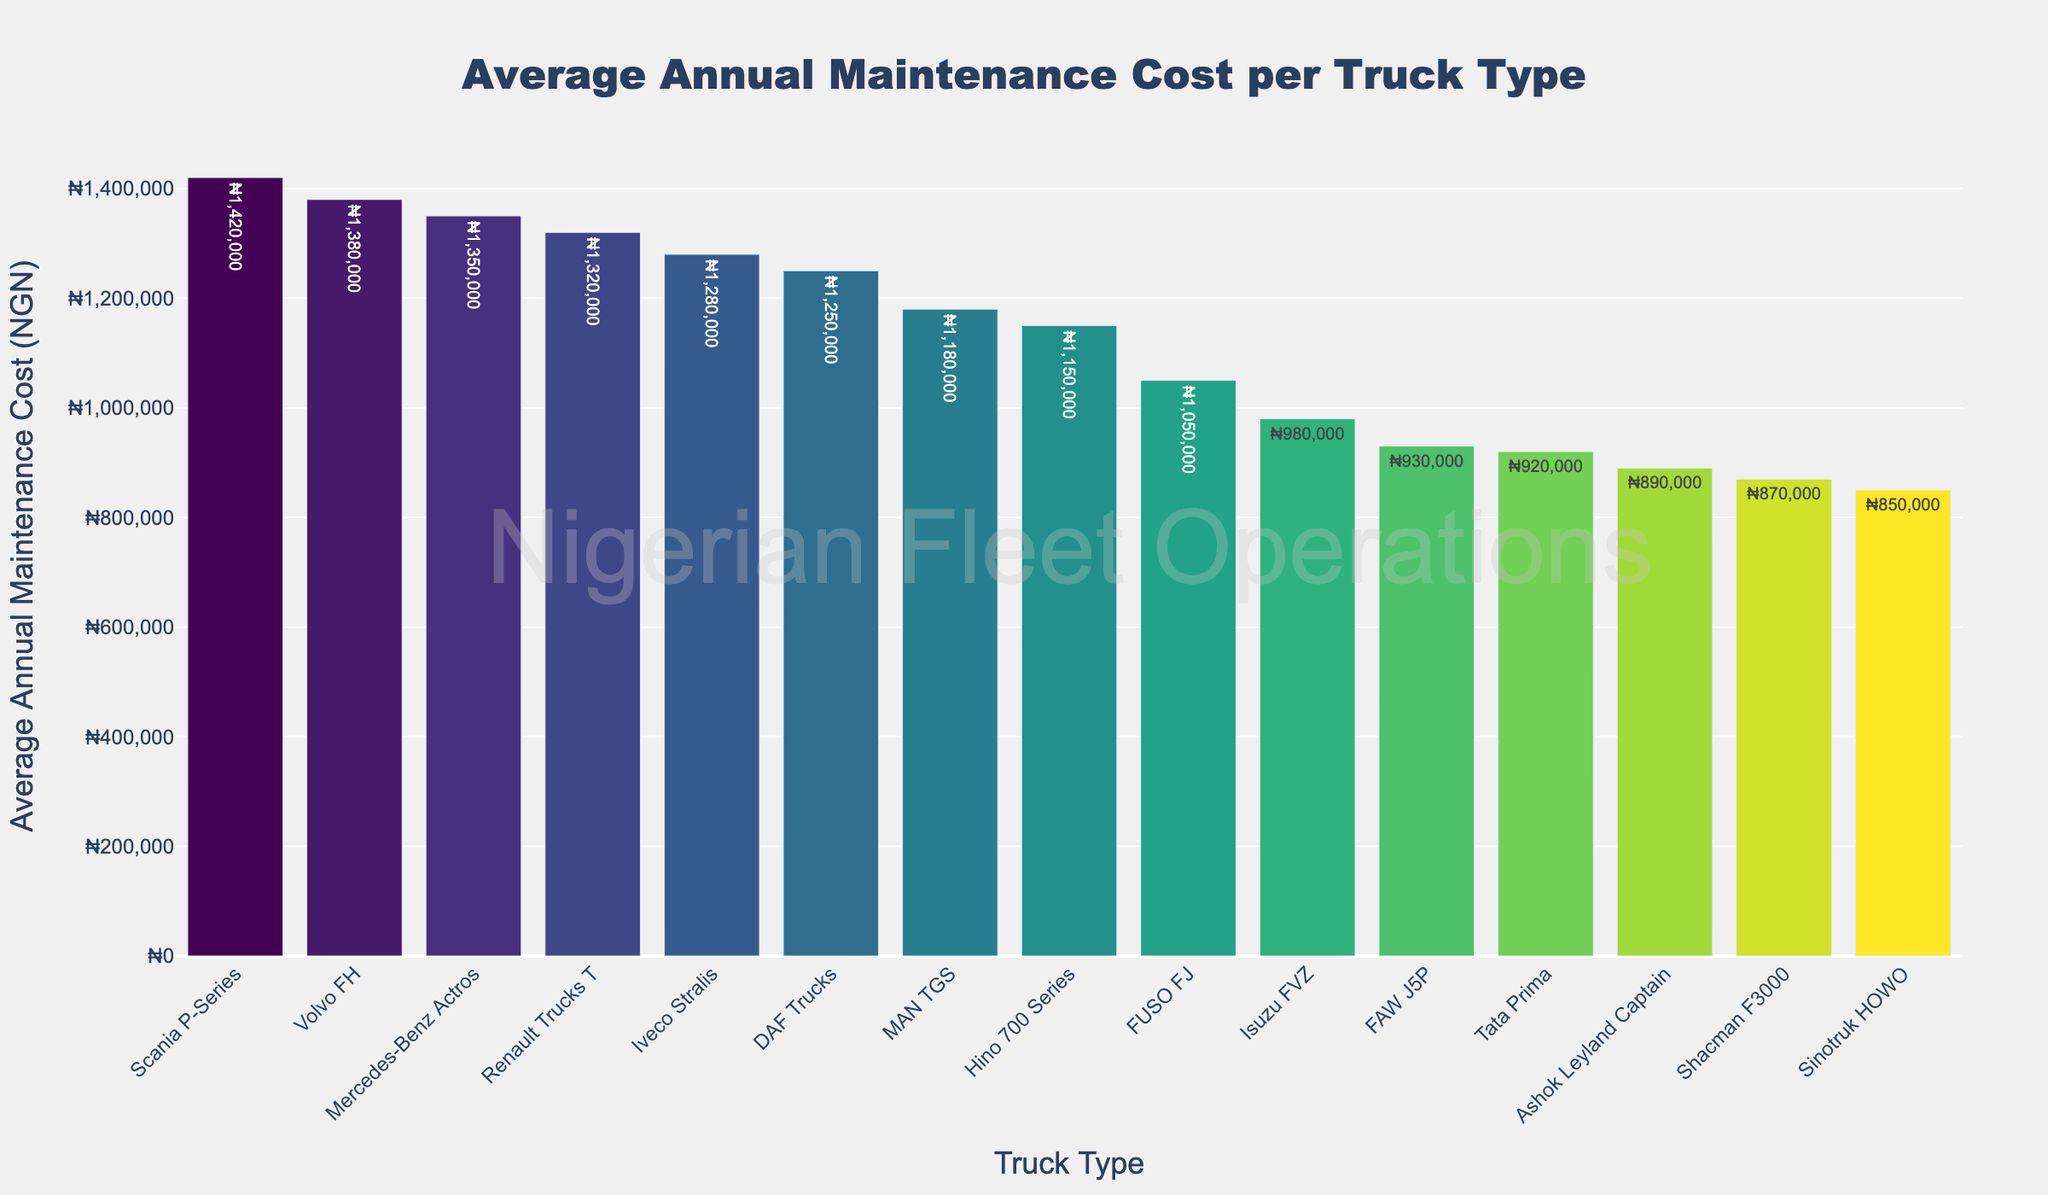Which truck type has the highest average annual maintenance cost? Look at the figure and identify the truck type with the tallest bar. The Scania P-Series has the tallest bar, indicating it has the highest average annual maintenance cost.
Answer: Scania P-Series Which truck type has the lowest average annual maintenance cost? Look at the figure and identify the truck type with the shortest bar. The Sinotruk HOWO has the shortest bar, indicating it has the lowest average annual maintenance cost.
Answer: Sinotruk HOWO What is the difference in average annual maintenance cost between Scania P-Series and Isuzu FVZ? Identify the bar heights for Scania P-Series and Isuzu FVZ. The Scania P-Series has an average annual maintenance cost of ₦1,420,000 and Isuzu FVZ has ₦980,000. Calculate the difference: ₦1,420,000 - ₦980,000 = ₦440,000.
Answer: ₦440,000 Which truck types have an average annual maintenance cost above ₦1,300,000? Look for truck types with bars above the ₦1,300,000 mark on the y-axis. The truck types are Scania P-Series, Volvo FH, Mercedes-Benz Actros, and Renault Trucks T.
Answer: Scania P-Series, Volvo FH, Mercedes-Benz Actros, Renault Trucks T What is the combined average annual maintenance cost of DAF Trucks and Mercedes-Benz Actros? Identify the bar heights for DAF Trucks and Mercedes-Benz Actros. DAF Trucks have ₦1,250,000 and Mercedes-Benz Actros have ₦1,350,000. Sum them up: ₦1,250,000 + ₦1,350,000 = ₦2,600,000.
Answer: ₦2,600,000 By how much does the average annual maintenance cost of Volvo FH exceed that of Renault Trucks T? Identify the bar heights for Volvo FH and Renault Trucks T. Volvo FH has ₦1,380,000 and Renault Trucks T has ₦1,320,000. Calculate the difference: ₦1,380,000 - ₦1,320,000 = ₦60,000.
Answer: ₦60,000 Which truck type has a maintenance cost closest to ₦1,000,000? Look for the bar that is nearest to the ₦1,000,000 mark on the y-axis. The FUSO FJ has an average annual maintenance cost of ₦1,050,000, which is the closest.
Answer: FUSO FJ How many truck types have an average annual maintenance cost below ₦1,000,000? Count the number of bars that are below the ₦1,000,000 mark on the y-axis. These bars belong to Isuzu FVZ, Sinotruk HOWO, Tata Prima, Ashok Leyland Captain, FAW J5P, and Shacman F3000. There are 6 in total.
Answer: 6 Which two truck types have the smallest difference in their average annual maintenance costs, and what is that difference? Compare the differences between maintenance costs of neighboring bars and identify the smallest difference. The smallest difference is between Renault Trucks T (₦1,320,000) and DAF Trucks (₦1,310,000): ₦1,320,000 - ₦1,310,000 = ₦10,000.
Answer: Renault Trucks T and DAF Trucks, ₦10,000 